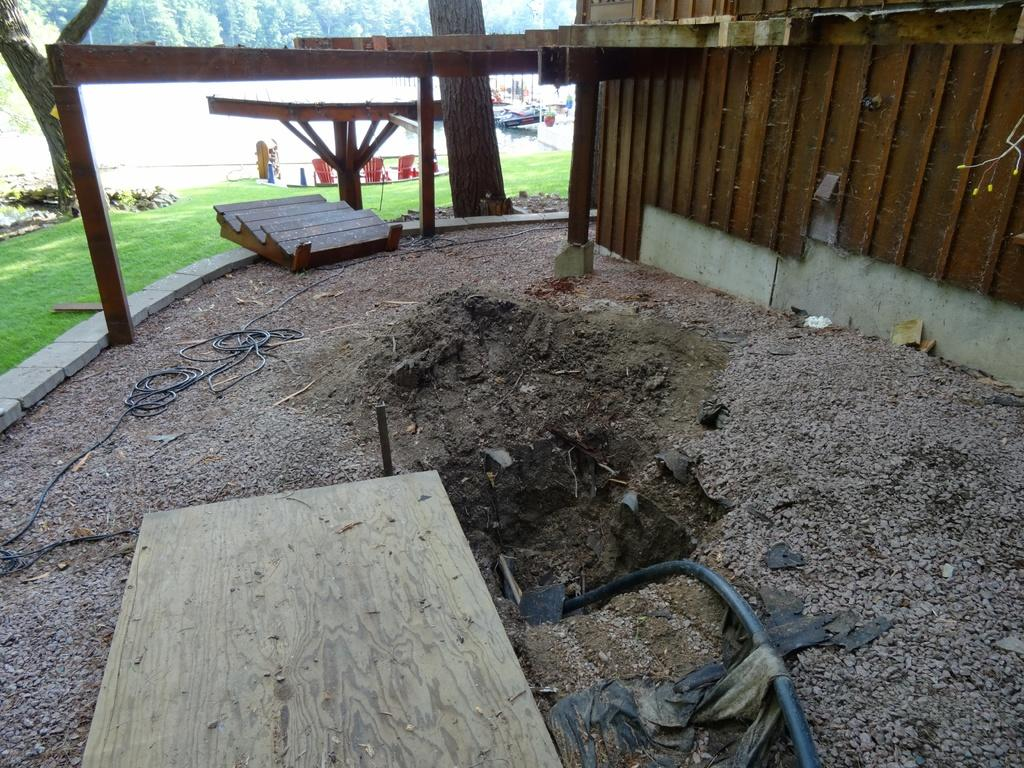What type of objects can be seen in the image that are used for connecting or transmitting? There are cables in the image that are used for connecting or transmitting. What type of object can be seen in the image that is used for transporting fluids? There is a pipe in the image that is used for transporting fluids. What type of natural vegetation can be seen in the image? There is grass in the image, which is a type of natural vegetation. What type of living organisms can be seen in the image? There are plants in the image, which are living organisms. What type of furniture can be seen in the image? There is a table in the image, which is a type of furniture. What type of objects can be seen in the background of the image that are used for seating? There are chairs in the background of the image, which are used for seating. What type of natural vegetation can be seen in the background of the image? There are trees in the background of the image, which are a type of natural vegetation. What type of brass instrument can be seen in the image? There is no brass instrument present in the image. What type of cherry tree can be seen in the image? There is no cherry tree present in the image. 